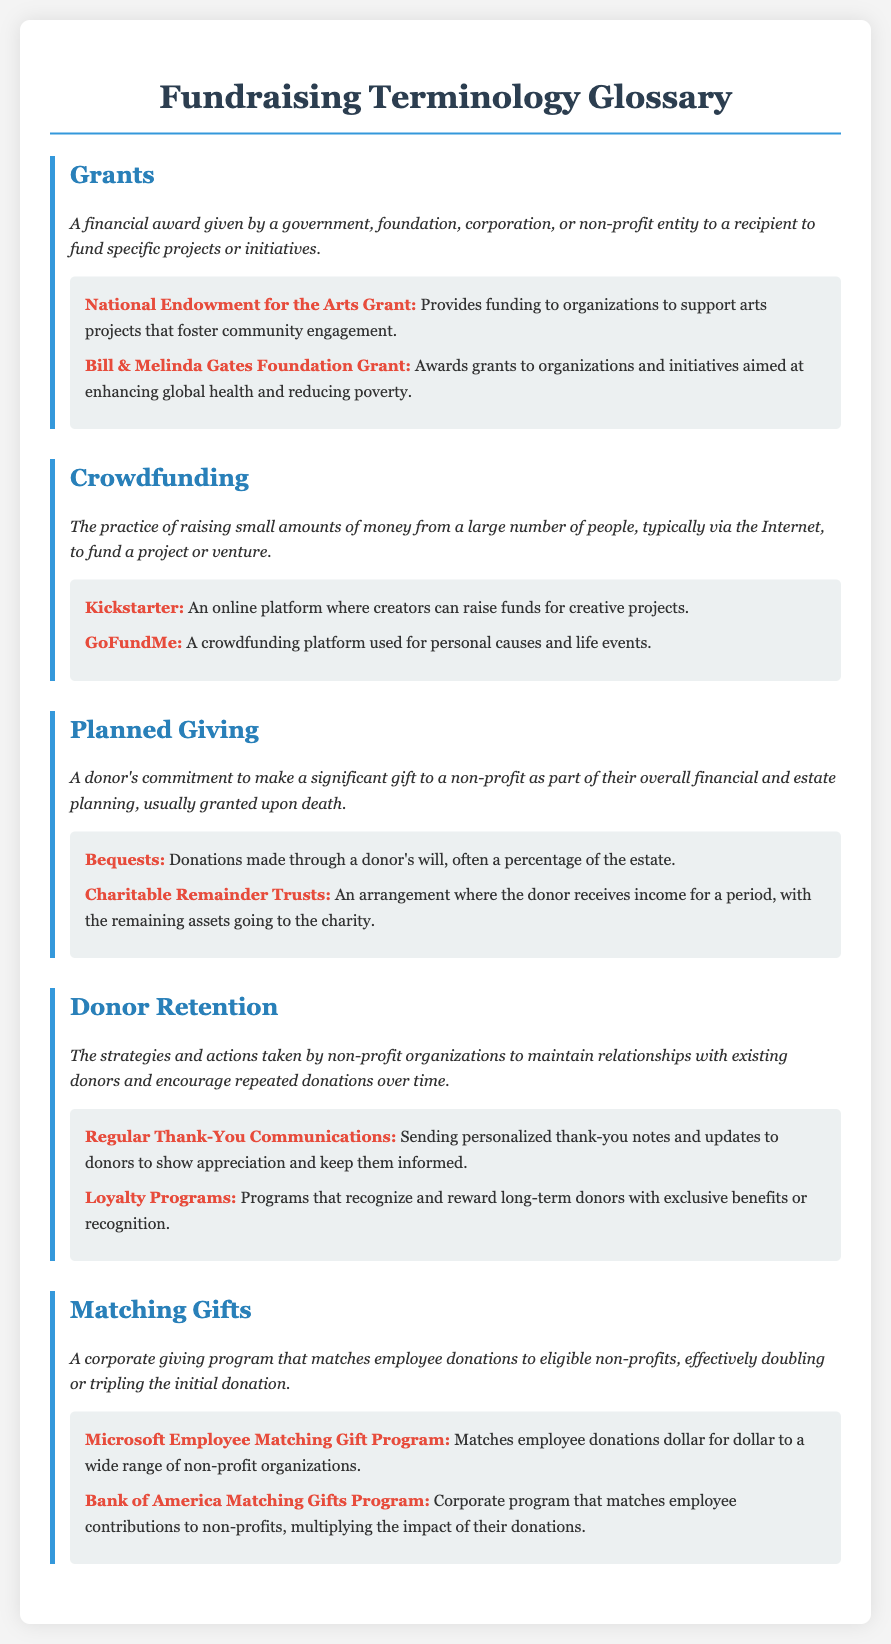What is a grant? A grant is a financial award given by a government, foundation, corporation, or non-profit entity to a recipient to fund specific projects or initiatives.
Answer: A financial award What is crowdfunding? Crowdfunding is the practice of raising small amounts of money from a large number of people, typically via the Internet, to fund a project or venture.
Answer: Raising small amounts What is planned giving? Planned giving is a donor's commitment to make a significant gift to a non-profit as part of their overall financial and estate planning, usually granted upon death.
Answer: A donor's commitment What are matching gifts? Matching gifts are a corporate giving program that matches employee donations to eligible non-profits, effectively doubling or tripling the initial donation.
Answer: Corporate giving program Name one example of a grant mentioned. The document lists grants such as the National Endowment for the Arts Grant and the Bill & Melinda Gates Foundation Grant.
Answer: National Endowment for the Arts Grant What strategy is used for donor retention? Strategies for donor retention include sending personalized thank-you notes and updates to donors.
Answer: Thank-You Communications What is an example of a crowdfunding platform? Examples of crowdfunding platforms include Kickstarter and GoFundMe.
Answer: GoFundMe How does Microsoft support matching gifts? Microsoft matches employee donations dollar for dollar to a wide range of non-profit organizations.
Answer: Dollar for dollar 